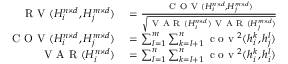Convert formula to latex. <formula><loc_0><loc_0><loc_500><loc_500>\begin{array} { r l } { R V ( H _ { i } ^ { n \times d } , H _ { j } ^ { m \times d } ) } & = \frac { C O V ( H _ { i } ^ { n \times d } , H _ { j } ^ { m \times d } ) } { \sqrt { V A R ( H _ { i } ^ { n \times d } ) V A R ( H _ { j } ^ { m \times d } ) } } } \\ { C O V ( H _ { i } ^ { n \times d } , H _ { j } ^ { m \times d } ) } & = \sum _ { l = 1 } ^ { m } \sum _ { k = l + 1 } ^ { n } c o v ^ { 2 } ( h _ { i } ^ { k } , h _ { j } ^ { l } ) } \\ { V A R ( H _ { i } ^ { n \times d } ) } & = \sum _ { l = 1 } ^ { n } \sum _ { k = l + 1 } ^ { n } c o v ^ { 2 } ( h _ { i } ^ { k } , h _ { i } ^ { l } ) } \end{array}</formula> 